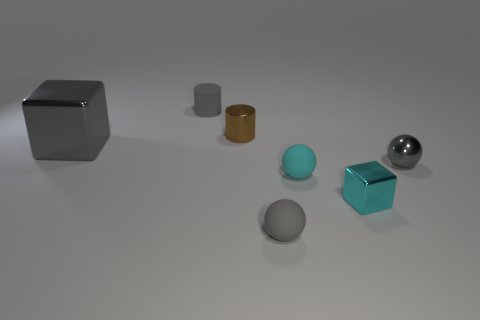Subtract all shiny spheres. How many spheres are left? 2 Add 3 brown metallic things. How many objects exist? 10 Subtract all gray spheres. How many spheres are left? 1 Subtract 1 cylinders. How many cylinders are left? 1 Subtract all cyan cylinders. Subtract all purple balls. How many cylinders are left? 2 Subtract all blue cylinders. How many cyan blocks are left? 1 Subtract all rubber things. Subtract all matte things. How many objects are left? 1 Add 2 tiny gray metallic objects. How many tiny gray metallic objects are left? 3 Add 4 big gray blocks. How many big gray blocks exist? 5 Subtract 1 cyan blocks. How many objects are left? 6 